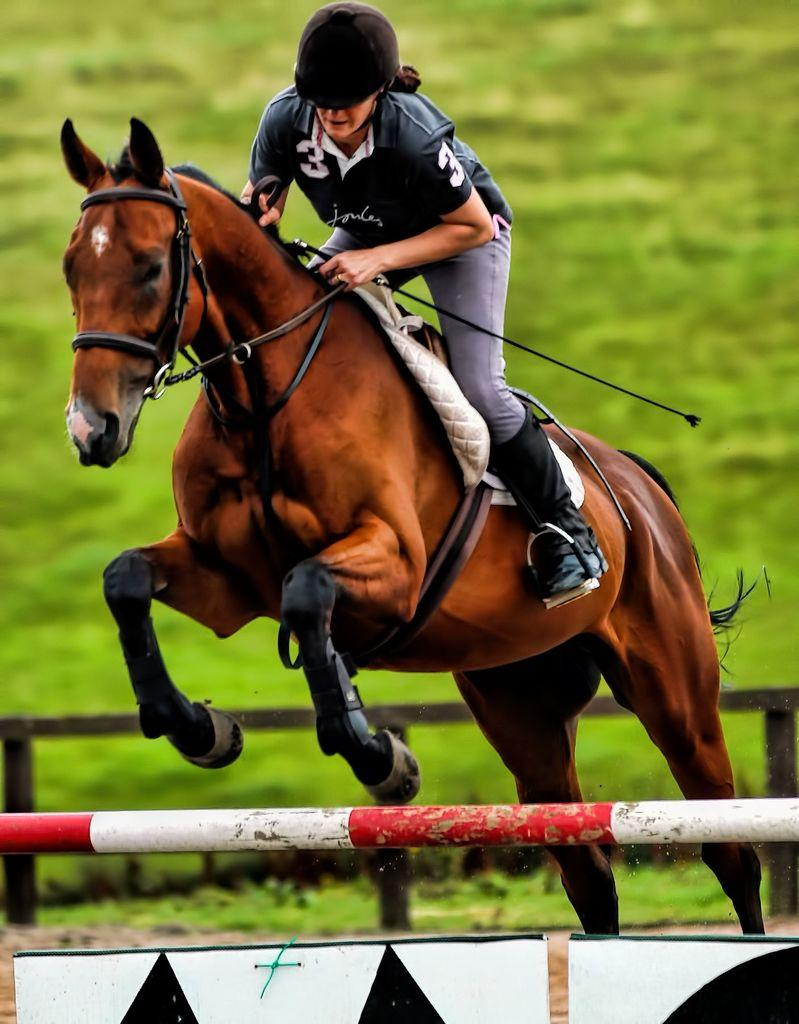Who is in the image? There is a woman in the image. What is the woman doing in the image? The woman is riding a horse. What is the woman holding in the image? The woman is holding a stick. What structures can be seen in the image? There is a pole, a sign board, and a fence in the image. What type of ground is visible in the image? There is grass on the ground in the image. What type of industry can be seen in the background of the image? There is no industry visible in the image; it features a woman riding a horse with a stick, a pole, a sign board, a fence, and grass on the ground. How does the woman express anger in the image? There is no indication of anger in the image; the woman is simply riding a horse and holding a stick. 